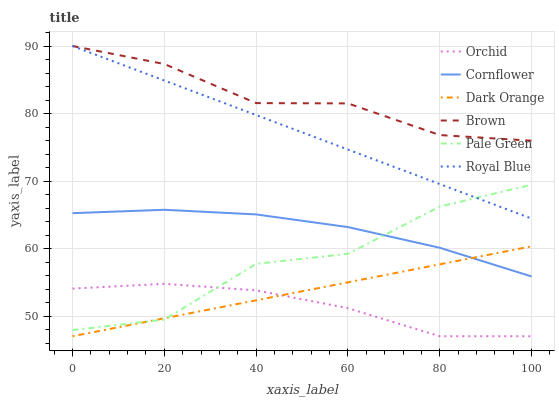Does Orchid have the minimum area under the curve?
Answer yes or no. Yes. Does Brown have the maximum area under the curve?
Answer yes or no. Yes. Does Cornflower have the minimum area under the curve?
Answer yes or no. No. Does Cornflower have the maximum area under the curve?
Answer yes or no. No. Is Dark Orange the smoothest?
Answer yes or no. Yes. Is Pale Green the roughest?
Answer yes or no. Yes. Is Brown the smoothest?
Answer yes or no. No. Is Brown the roughest?
Answer yes or no. No. Does Dark Orange have the lowest value?
Answer yes or no. Yes. Does Cornflower have the lowest value?
Answer yes or no. No. Does Royal Blue have the highest value?
Answer yes or no. Yes. Does Cornflower have the highest value?
Answer yes or no. No. Is Dark Orange less than Brown?
Answer yes or no. Yes. Is Cornflower greater than Orchid?
Answer yes or no. Yes. Does Orchid intersect Pale Green?
Answer yes or no. Yes. Is Orchid less than Pale Green?
Answer yes or no. No. Is Orchid greater than Pale Green?
Answer yes or no. No. Does Dark Orange intersect Brown?
Answer yes or no. No. 